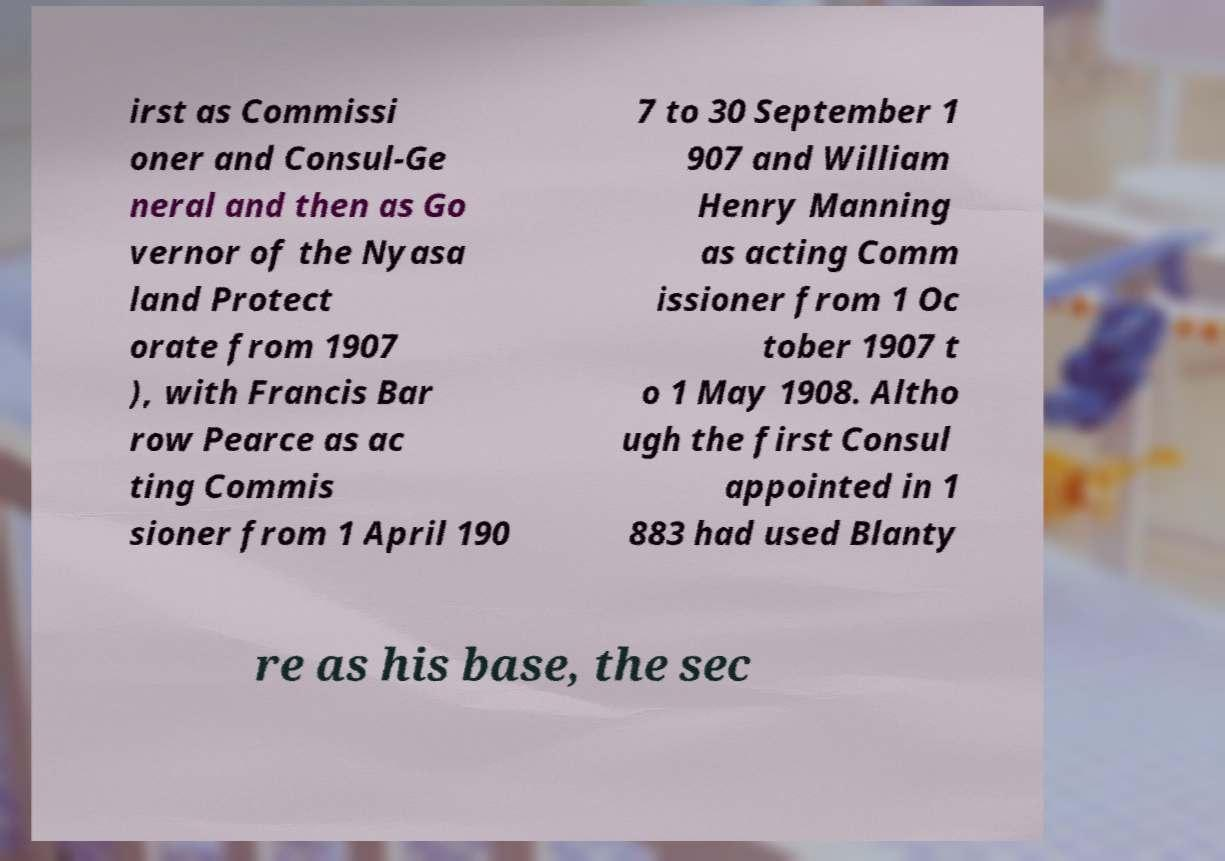What messages or text are displayed in this image? I need them in a readable, typed format. irst as Commissi oner and Consul-Ge neral and then as Go vernor of the Nyasa land Protect orate from 1907 ), with Francis Bar row Pearce as ac ting Commis sioner from 1 April 190 7 to 30 September 1 907 and William Henry Manning as acting Comm issioner from 1 Oc tober 1907 t o 1 May 1908. Altho ugh the first Consul appointed in 1 883 had used Blanty re as his base, the sec 